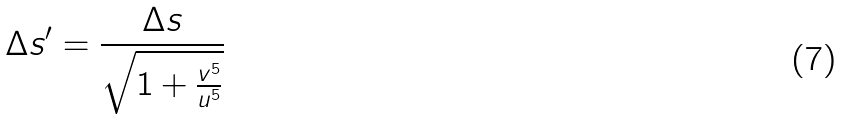Convert formula to latex. <formula><loc_0><loc_0><loc_500><loc_500>\Delta s ^ { \prime } = \frac { \Delta s } { \sqrt { 1 + \frac { v ^ { 5 } } { u ^ { 5 } } } }</formula> 